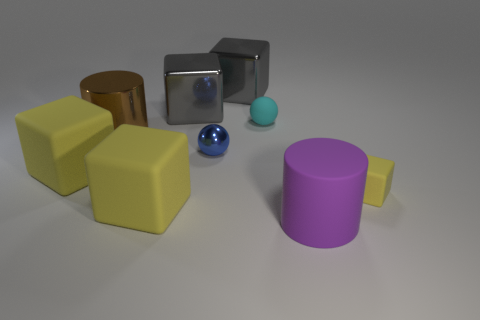Subtract all yellow cubes. How many were subtracted if there are1yellow cubes left? 2 Subtract all yellow cylinders. How many yellow blocks are left? 3 Subtract all rubber blocks. How many blocks are left? 2 Add 1 blue shiny spheres. How many objects exist? 10 Subtract 4 blocks. How many blocks are left? 1 Subtract all brown cylinders. How many cylinders are left? 1 Subtract all balls. How many objects are left? 7 Add 2 blue spheres. How many blue spheres exist? 3 Subtract 0 yellow cylinders. How many objects are left? 9 Subtract all yellow cylinders. Subtract all yellow cubes. How many cylinders are left? 2 